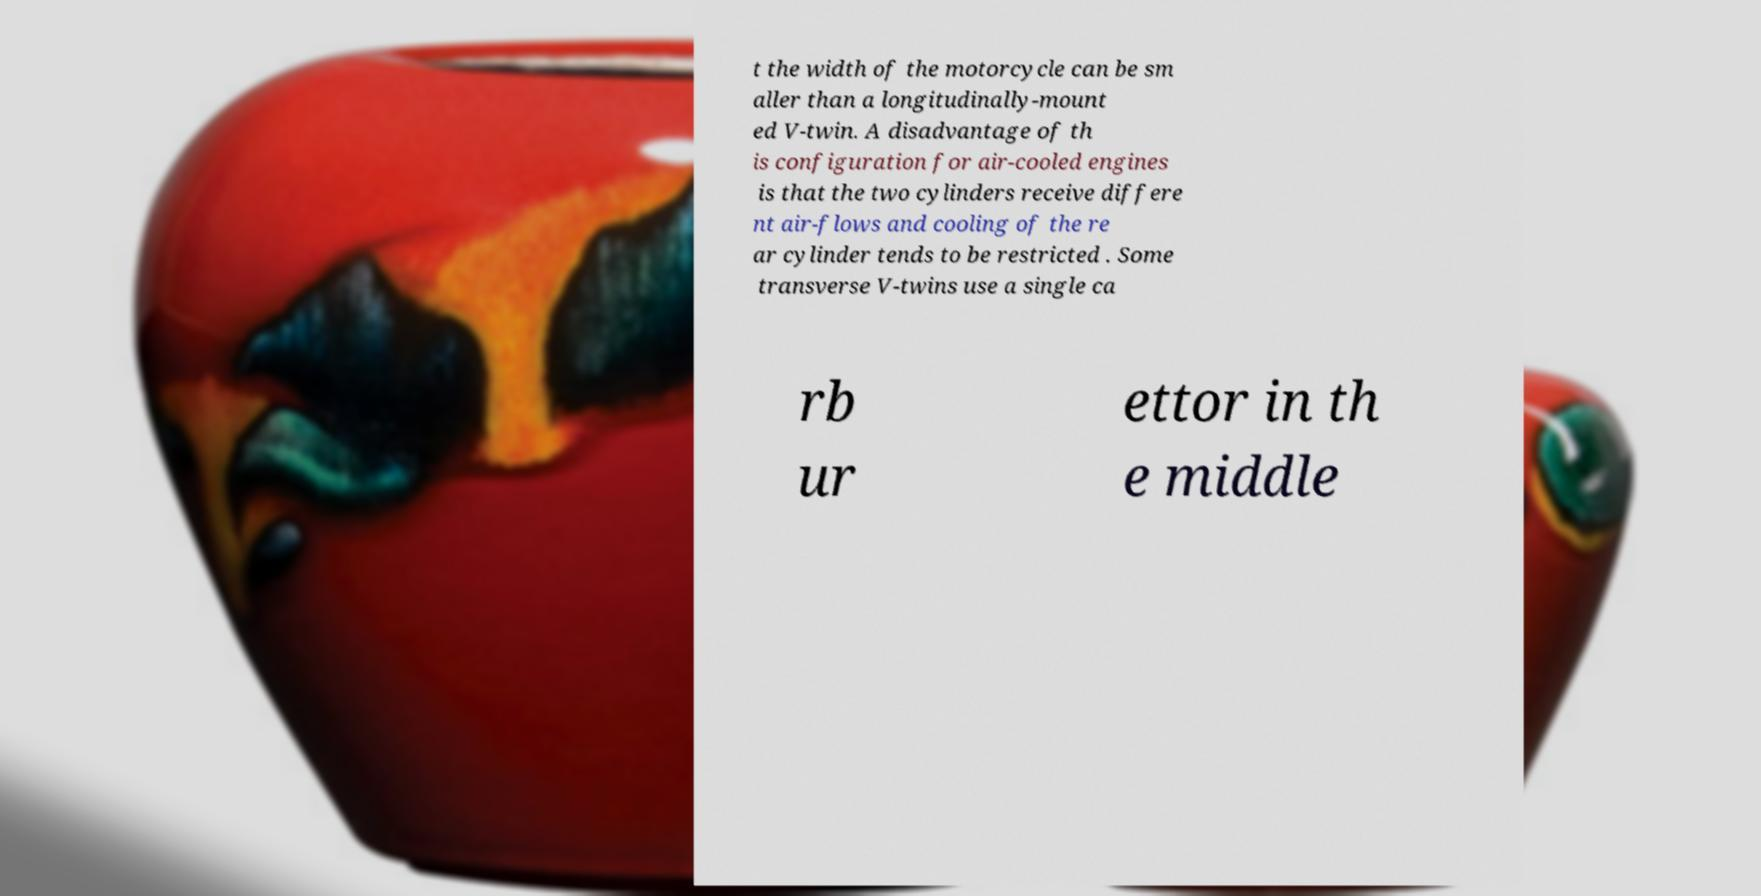Could you assist in decoding the text presented in this image and type it out clearly? t the width of the motorcycle can be sm aller than a longitudinally-mount ed V-twin. A disadvantage of th is configuration for air-cooled engines is that the two cylinders receive differe nt air-flows and cooling of the re ar cylinder tends to be restricted . Some transverse V-twins use a single ca rb ur ettor in th e middle 